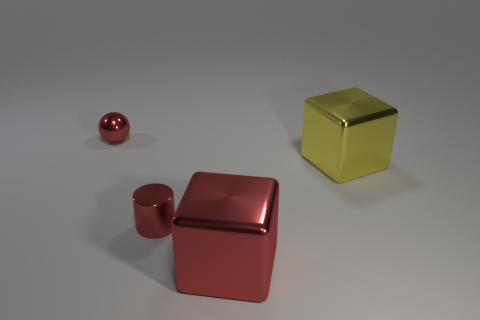There is a big metallic object that is left of the metallic thing to the right of the red metallic cube; what is its shape?
Keep it short and to the point. Cube. What number of other things are the same shape as the large red thing?
Make the answer very short. 1. There is a metallic object behind the big metal object that is behind the red metallic cube; how big is it?
Offer a terse response. Small. Is there a large red block?
Provide a succinct answer. Yes. What number of big red metal blocks are behind the tiny metallic object that is in front of the red metal ball?
Your answer should be compact. 0. What is the shape of the tiny object in front of the yellow metal block?
Keep it short and to the point. Cylinder. The cube that is to the right of the large thing in front of the cube that is right of the big red object is made of what material?
Provide a short and direct response. Metal. What number of other things are there of the same size as the red metallic cylinder?
Your answer should be compact. 1. There is another thing that is the same shape as the large yellow thing; what is it made of?
Provide a succinct answer. Metal. The small cylinder is what color?
Make the answer very short. Red. 